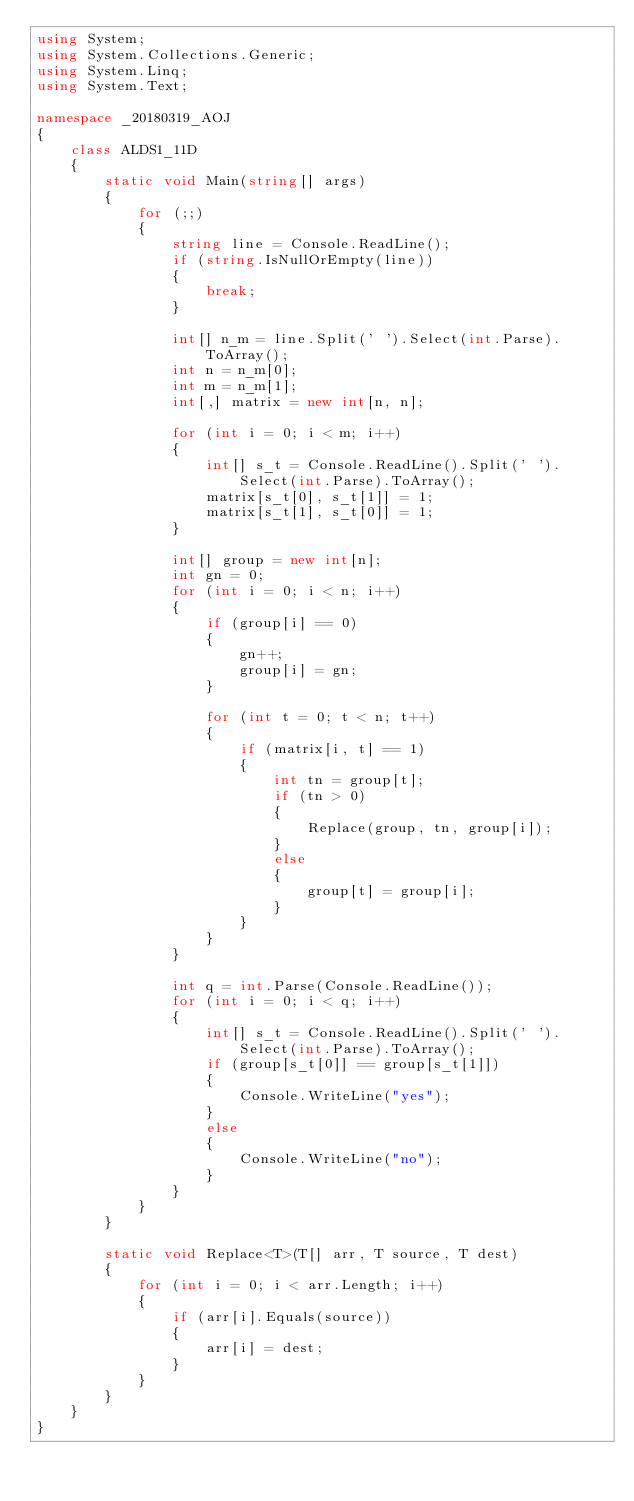Convert code to text. <code><loc_0><loc_0><loc_500><loc_500><_C#_>using System;
using System.Collections.Generic;
using System.Linq;
using System.Text;

namespace _20180319_AOJ
{
    class ALDS1_11D
    {
        static void Main(string[] args)
        {
            for (;;)
            {
                string line = Console.ReadLine();
                if (string.IsNullOrEmpty(line))
                {
                    break;
                }

                int[] n_m = line.Split(' ').Select(int.Parse).ToArray();
                int n = n_m[0];
                int m = n_m[1];
                int[,] matrix = new int[n, n];

                for (int i = 0; i < m; i++)
                {
                    int[] s_t = Console.ReadLine().Split(' ').Select(int.Parse).ToArray();
                    matrix[s_t[0], s_t[1]] = 1;
                    matrix[s_t[1], s_t[0]] = 1;
                }

                int[] group = new int[n];
                int gn = 0;
                for (int i = 0; i < n; i++)
                {
                    if (group[i] == 0)
                    {
                        gn++;
                        group[i] = gn;
                    }
                    
                    for (int t = 0; t < n; t++)
                    {
                        if (matrix[i, t] == 1)
                        {
                            int tn = group[t];
                            if (tn > 0)
                            {
                                Replace(group, tn, group[i]);
                            }
                            else
                            {
                                group[t] = group[i];
                            }
                        }
                    }
                }

                int q = int.Parse(Console.ReadLine());
                for (int i = 0; i < q; i++)
                {
                    int[] s_t = Console.ReadLine().Split(' ').Select(int.Parse).ToArray();
                    if (group[s_t[0]] == group[s_t[1]])
                    {
                        Console.WriteLine("yes");
                    }
                    else
                    {
                        Console.WriteLine("no");
                    }
                }
            }
        }

        static void Replace<T>(T[] arr, T source, T dest)
        {
            for (int i = 0; i < arr.Length; i++)
            {
                if (arr[i].Equals(source))
                {
                    arr[i] = dest;
                }
            }
        }
    }
}

</code> 